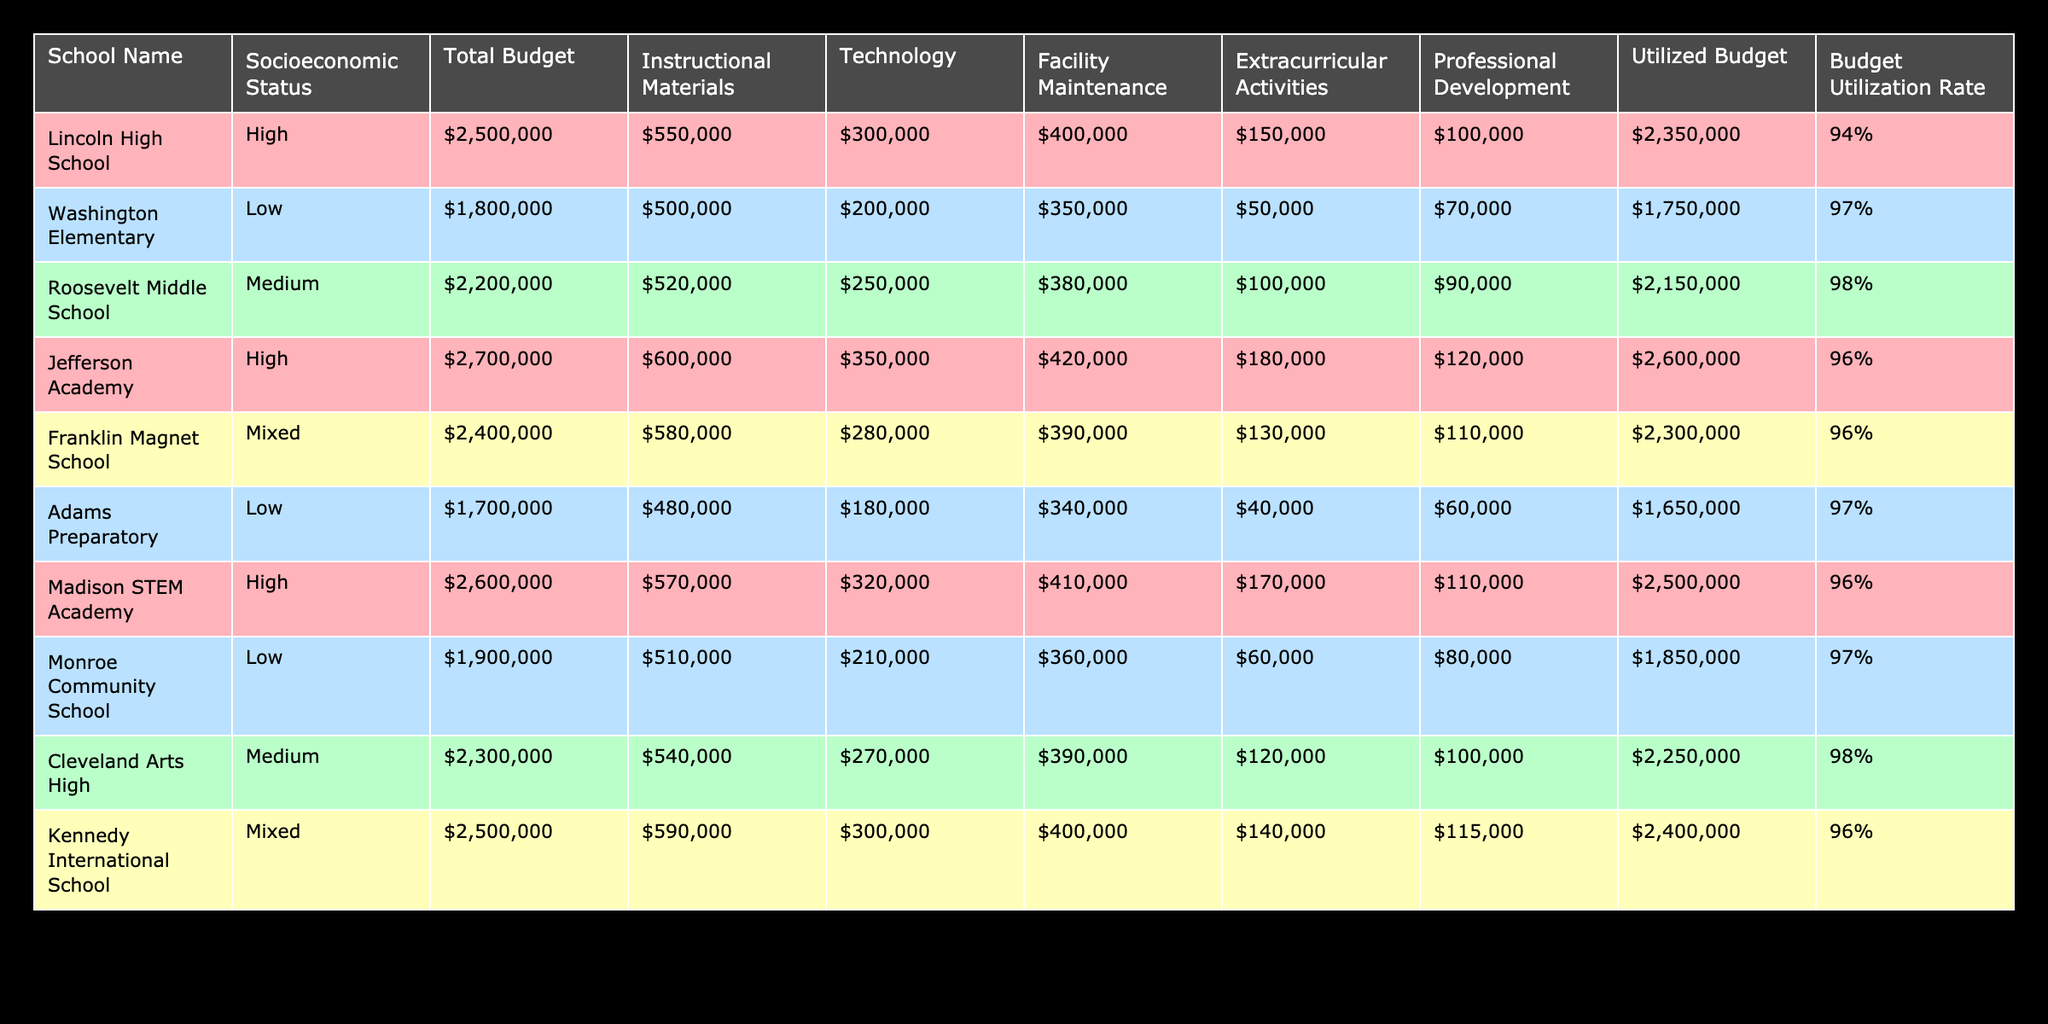What is the total budget allocated to Lincoln High School? The total budget for Lincoln High School is listed directly in the table under the 'Total Budget' column. It shows an amount of 2,500,000.
Answer: 2,500,000 What is the budget utilization rate for Roosevelt Middle School? The budget utilization rate is mentioned in the table for each school. For Roosevelt Middle School, it is stated as 98%.
Answer: 98% Which school has the highest budget utilization rate among low socioeconomic status schools? From the table, we identify the two schools with low socioeconomic status: Washington Elementary and Adams Preparatory. Their utilization rates are 97% and 97% respectively, indicating that both have the same rate.
Answer: 97% What is the difference between the total budgets of the highest and lowest funded schools? Looking at the total budgets listed, Jefferson Academy has the highest total budget of 2,700,000, and Adams Preparatory has the lowest total budget of 1,700,000. The difference is calculated as 2,700,000 - 1,700,000 = 1,000,000.
Answer: 1,000,000 Is it true that all schools with a high socioeconomic status have a budget utilization rate of at least 94%? Checking the budget utilization rates for high socioeconomic status schools: Lincoln High School (94%), Jefferson Academy (96%), and Madison STEM Academy (96%), confirms that all exceed this threshold. Therefore, the statement is true.
Answer: Yes What is the average utilized budget for schools with medium socioeconomic status? The schools with medium socioeconomic status are Roosevelt Middle School and Cleveland Arts High. Their utilized budgets are 2,150,000 and 2,250,000, respectively. The average is calculated as (2,150,000 + 2,250,000) / 2 = 2,200,000.
Answer: 2,200,000 How many schools have a budget utilization rate above 95%? Reviewing the table, the schools with rates above 95% are Roosevelt Middle School (98%), Washington Elementary (97%), Cleveland Arts High (98%), and others. Counting these gives us a total of six schools with rates above 95%.
Answer: 6 Which budget category received the most funding at Lincoln High School? By examining Lincoln High School’s budget allocation across different categories, we find Instructional Materials received 550,000, which is the highest amount compared to the other categories such as Technology (300,000), Facility Maintenance (400,000), etc.
Answer: Instructional Materials 